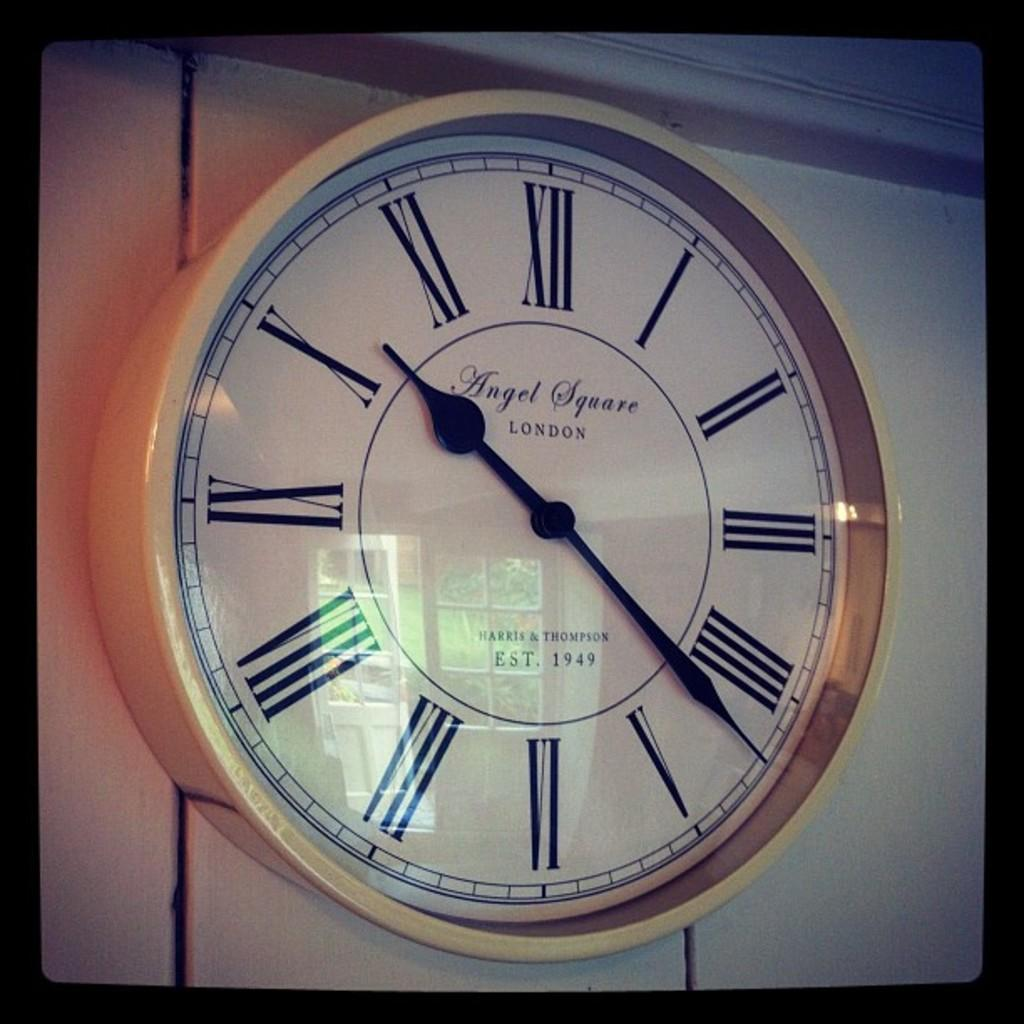<image>
Relay a brief, clear account of the picture shown. A clock says Angel Square London on its face. 